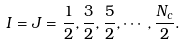Convert formula to latex. <formula><loc_0><loc_0><loc_500><loc_500>I = J = \frac { 1 } { 2 } , \frac { 3 } { 2 } , \frac { 5 } { 2 } , \cdots , \frac { N _ { c } } { 2 } .</formula> 